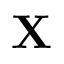<formula> <loc_0><loc_0><loc_500><loc_500>X</formula> 